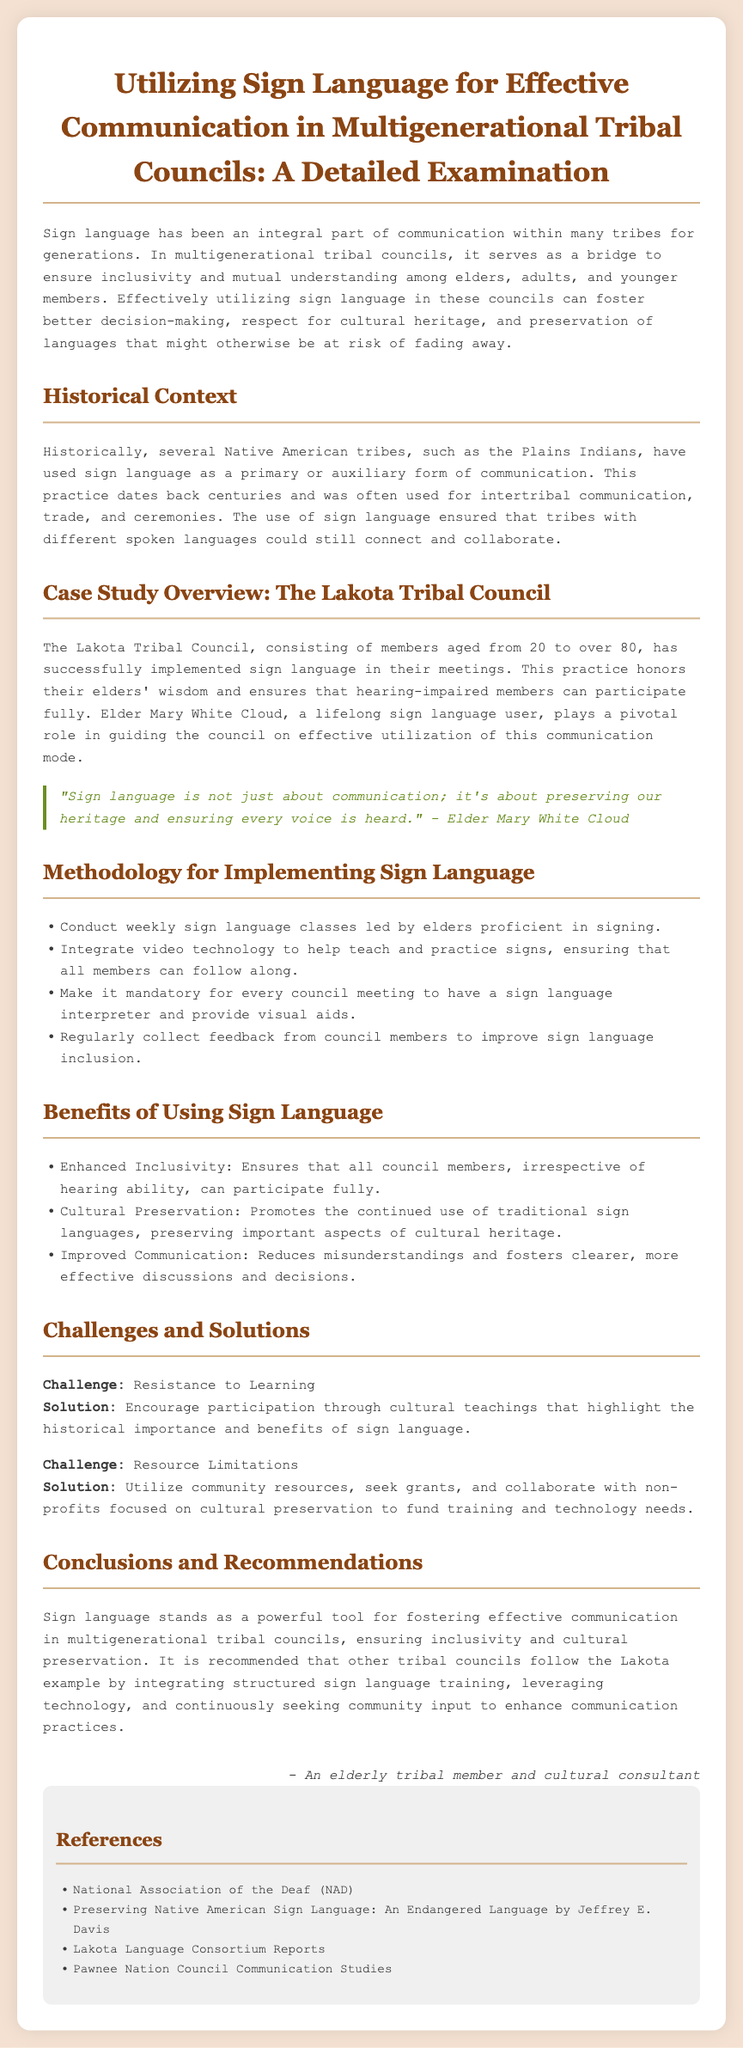What is the main focus of the case study? The case study focuses on utilizing sign language for effective communication in multigenerational tribal councils.
Answer: Utilizing sign language for effective communication Who plays a pivotal role in guiding the Lakota Tribal Council? Elder Mary White Cloud is mentioned as a key figure in guiding the council on using sign language.
Answer: Elder Mary White Cloud What is one of the benefits of using sign language mentioned in the document? The document lists several benefits, including enhanced inclusivity, cultural preservation, and improved communication.
Answer: Enhanced Inclusivity What is one challenge related to implementing sign language? Resistance to learning is highlighted as a challenge faced by councils.
Answer: Resistance to Learning How often are sign language classes conducted for the council? The document states that sign language classes are conducted weekly.
Answer: Weekly 